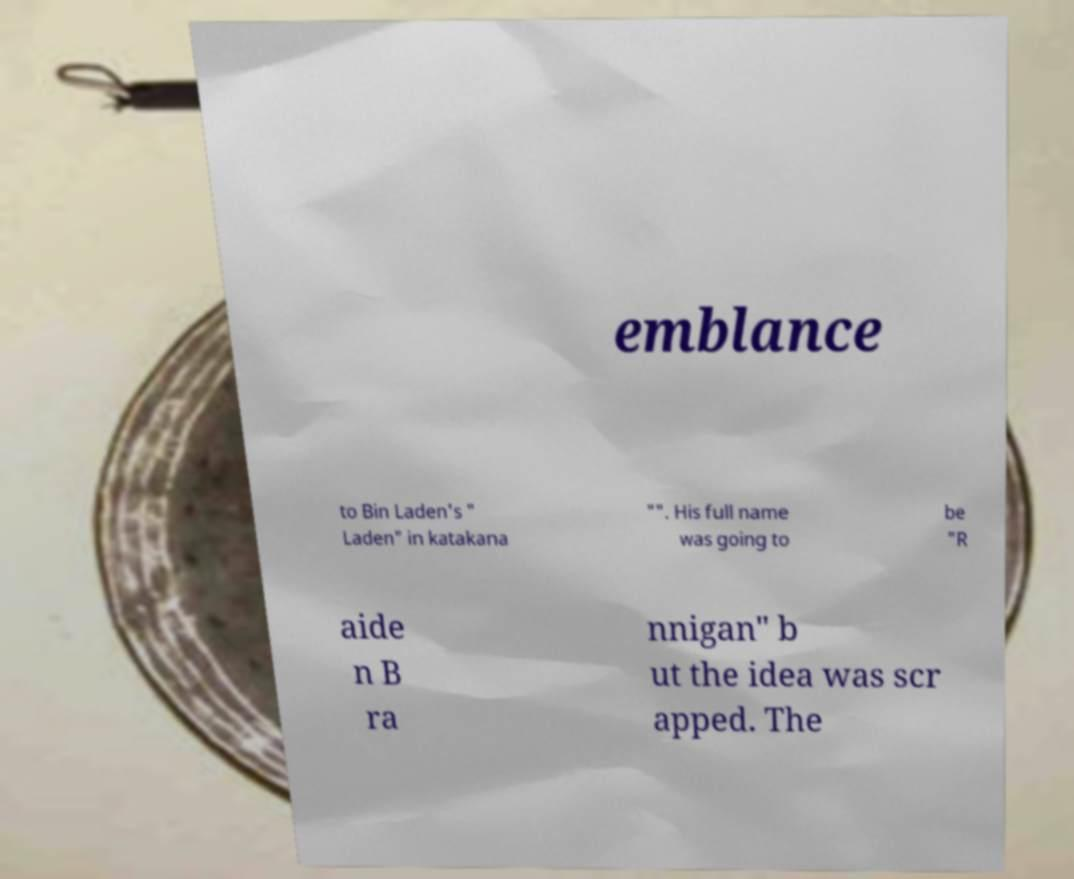For documentation purposes, I need the text within this image transcribed. Could you provide that? emblance to Bin Laden's " Laden" in katakana "". His full name was going to be "R aide n B ra nnigan" b ut the idea was scr apped. The 